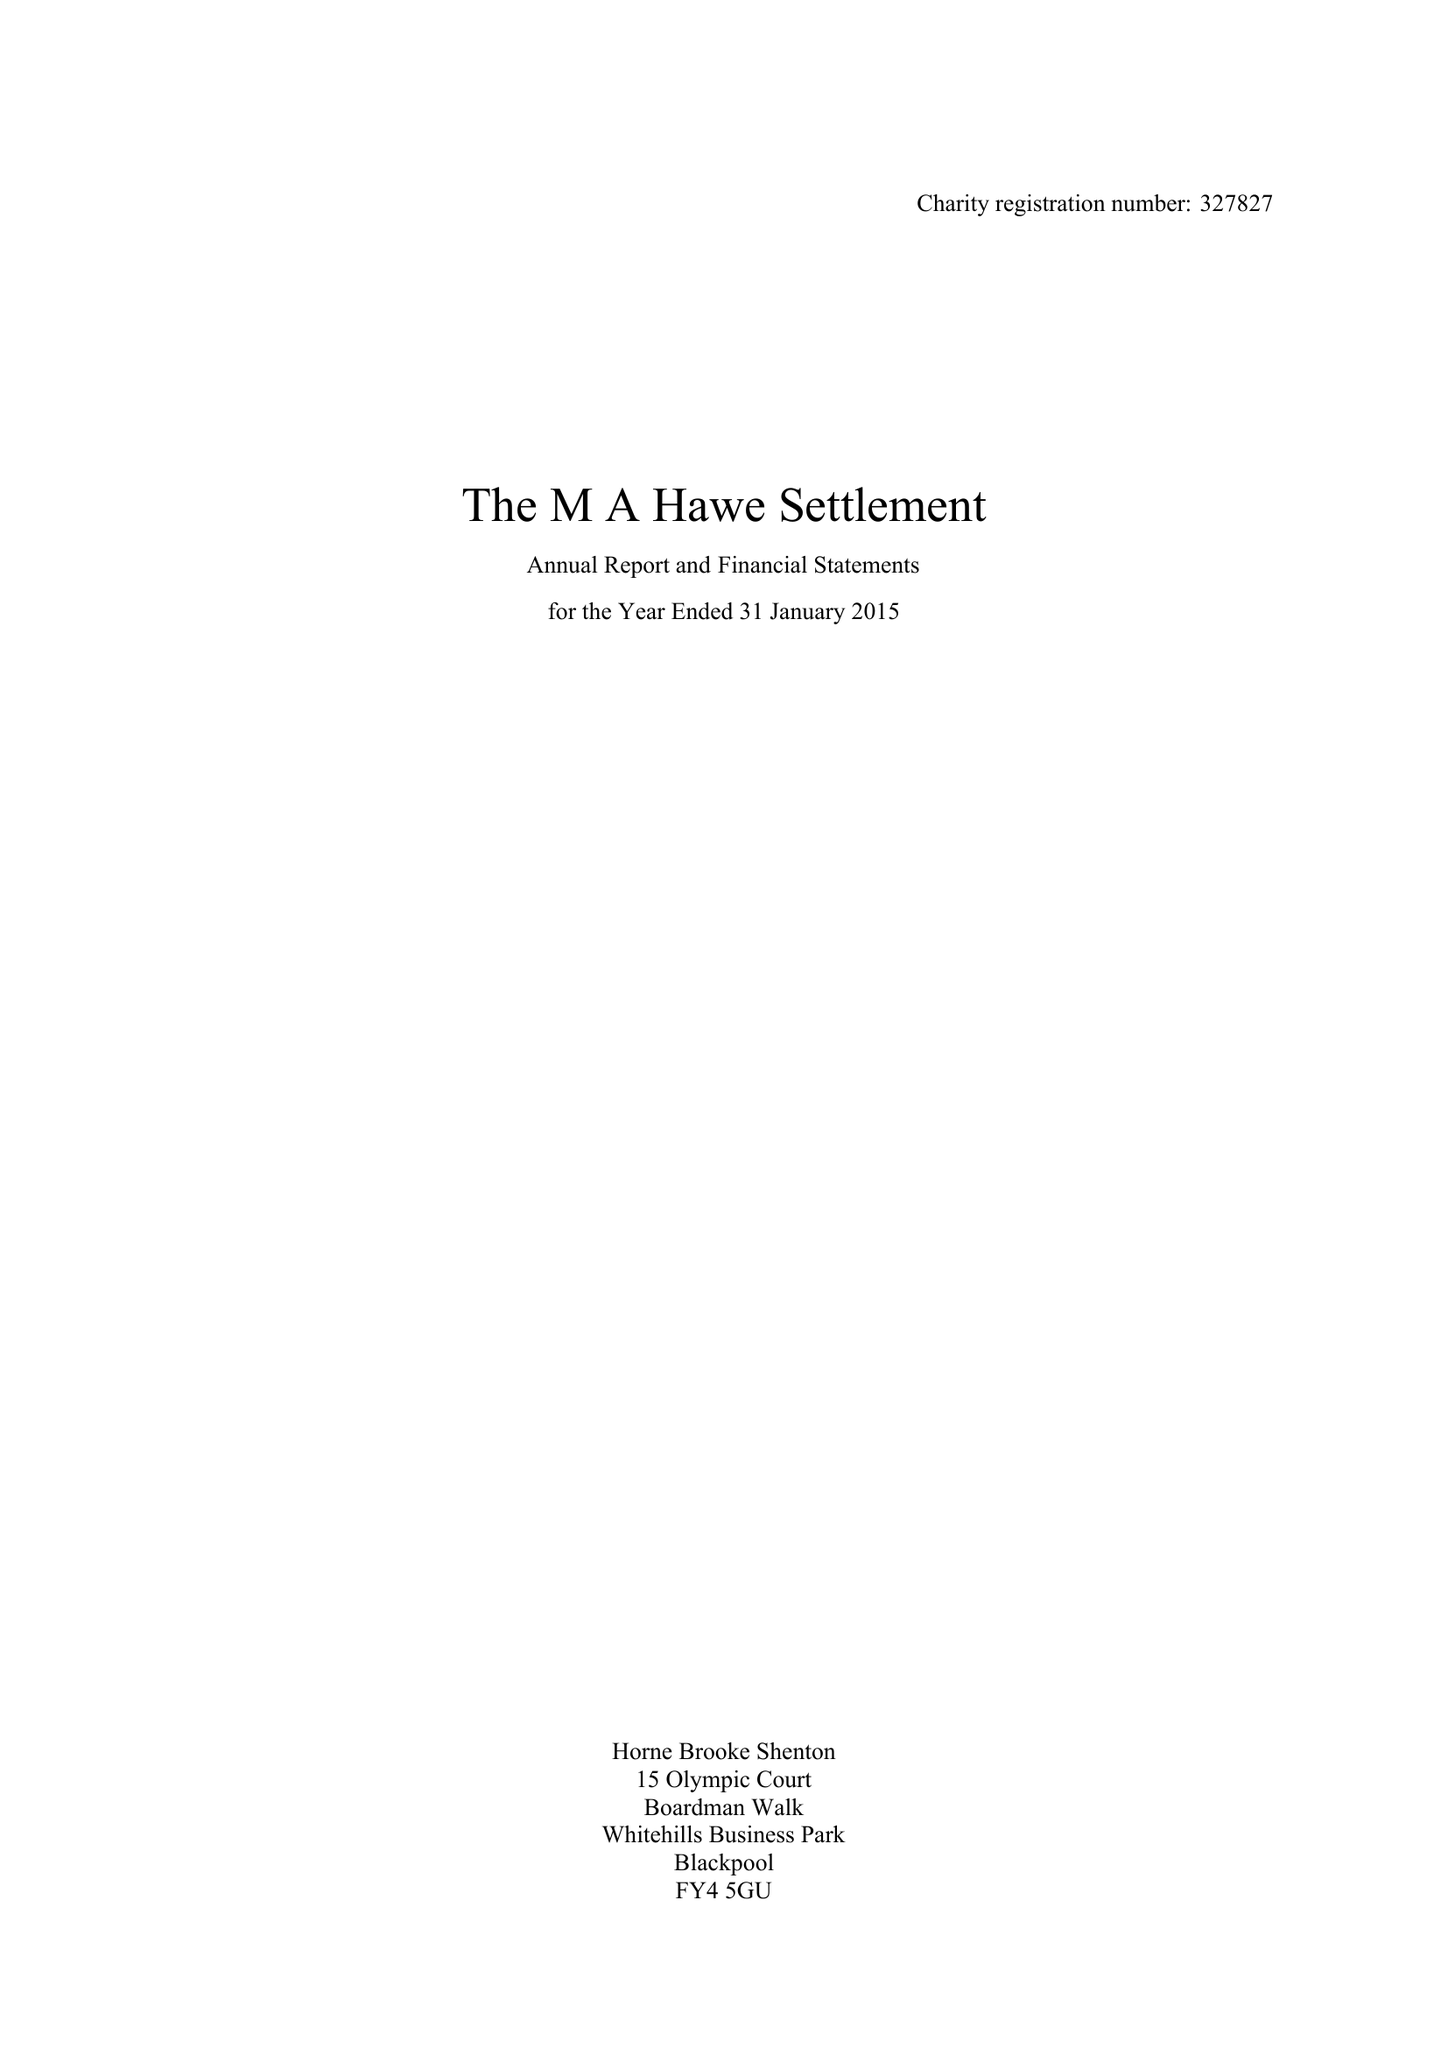What is the value for the report_date?
Answer the question using a single word or phrase. 2015-01-31 